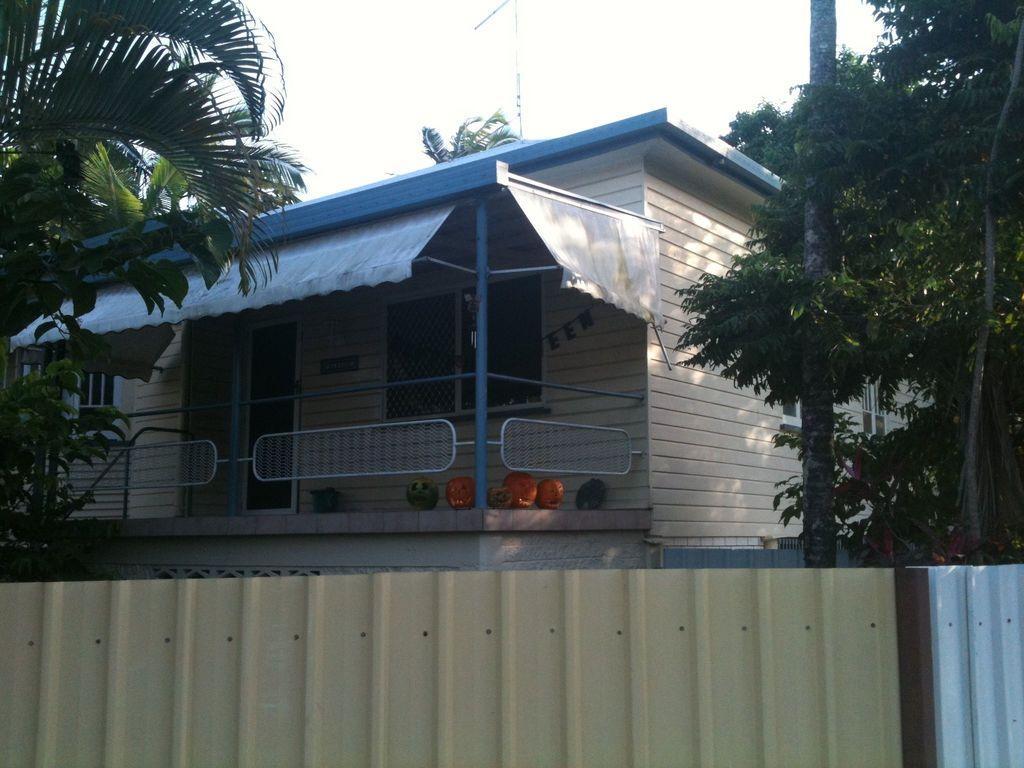Could you give a brief overview of what you see in this image? In this picture we can see a building with windows, pumpkins, trees, wall and in the background we can see the sky. 